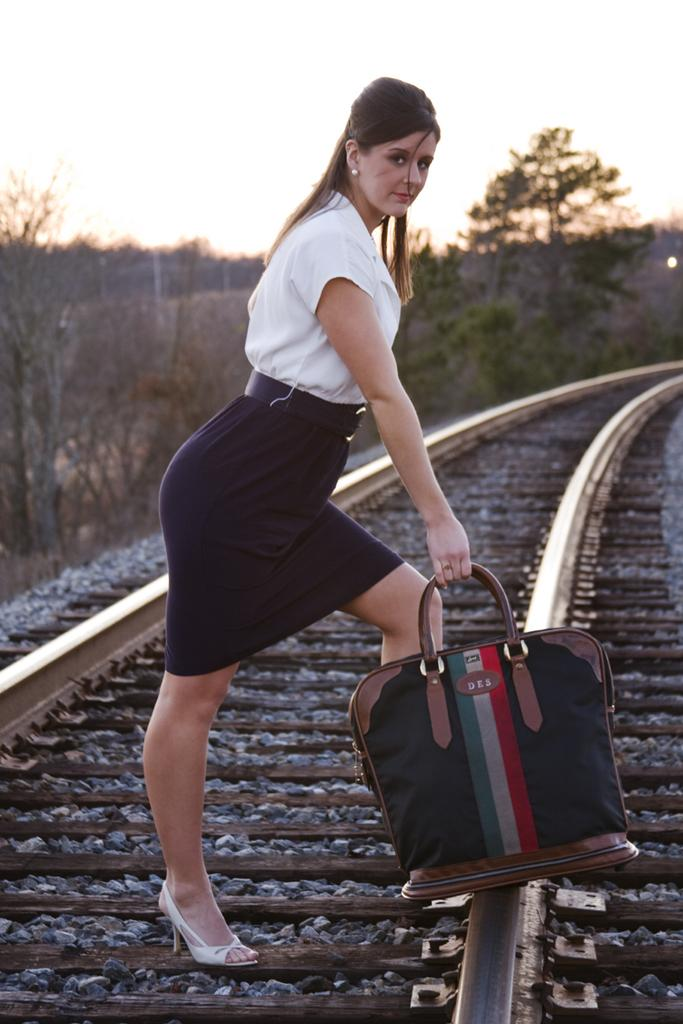What can be seen in the sky in the image? The sky is visible in the image. What type of vegetation is present in the image? There are trees in the image, including a bare tree. What is the woman in the image doing? The woman is standing on a railway track. What is the woman holding in her hand? The woman is holding a bag in her hand. How many eggs can be seen floating in the sky in the image? There are no eggs visible in the sky in the image. 